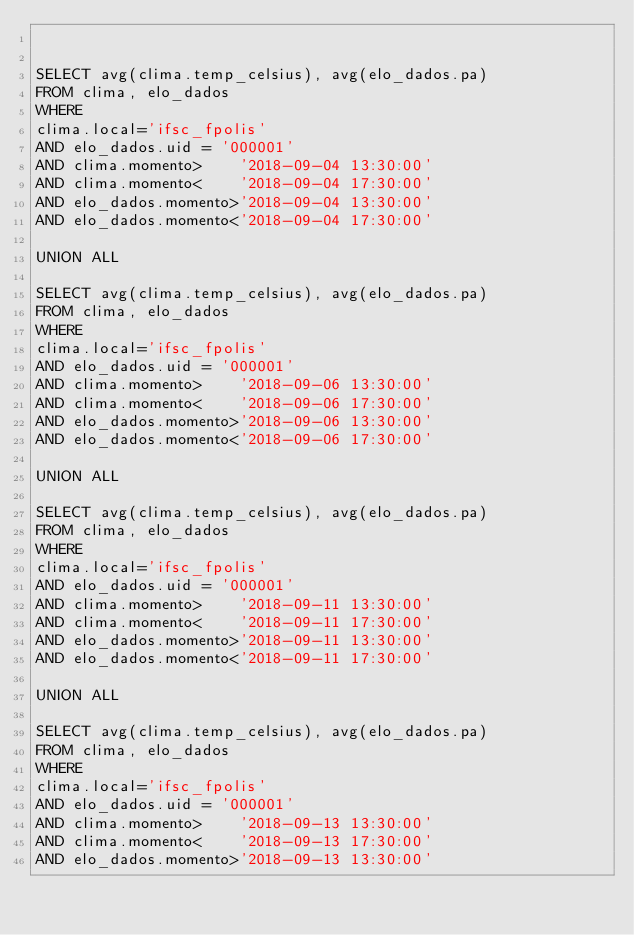<code> <loc_0><loc_0><loc_500><loc_500><_SQL_>

SELECT avg(clima.temp_celsius), avg(elo_dados.pa)
FROM clima, elo_dados
WHERE
clima.local='ifsc_fpolis'
AND elo_dados.uid = '000001'
AND clima.momento>    '2018-09-04 13:30:00'
AND clima.momento<    '2018-09-04 17:30:00'
AND elo_dados.momento>'2018-09-04 13:30:00'
AND elo_dados.momento<'2018-09-04 17:30:00'

UNION ALL

SELECT avg(clima.temp_celsius), avg(elo_dados.pa)
FROM clima, elo_dados
WHERE
clima.local='ifsc_fpolis'
AND elo_dados.uid = '000001'
AND clima.momento>    '2018-09-06 13:30:00'
AND clima.momento<    '2018-09-06 17:30:00'
AND elo_dados.momento>'2018-09-06 13:30:00'
AND elo_dados.momento<'2018-09-06 17:30:00'

UNION ALL

SELECT avg(clima.temp_celsius), avg(elo_dados.pa)
FROM clima, elo_dados
WHERE
clima.local='ifsc_fpolis'
AND elo_dados.uid = '000001'
AND clima.momento>    '2018-09-11 13:30:00'
AND clima.momento<    '2018-09-11 17:30:00'
AND elo_dados.momento>'2018-09-11 13:30:00'
AND elo_dados.momento<'2018-09-11 17:30:00'

UNION ALL

SELECT avg(clima.temp_celsius), avg(elo_dados.pa)
FROM clima, elo_dados
WHERE
clima.local='ifsc_fpolis'
AND elo_dados.uid = '000001'
AND clima.momento>    '2018-09-13 13:30:00'
AND clima.momento<    '2018-09-13 17:30:00'
AND elo_dados.momento>'2018-09-13 13:30:00'</code> 